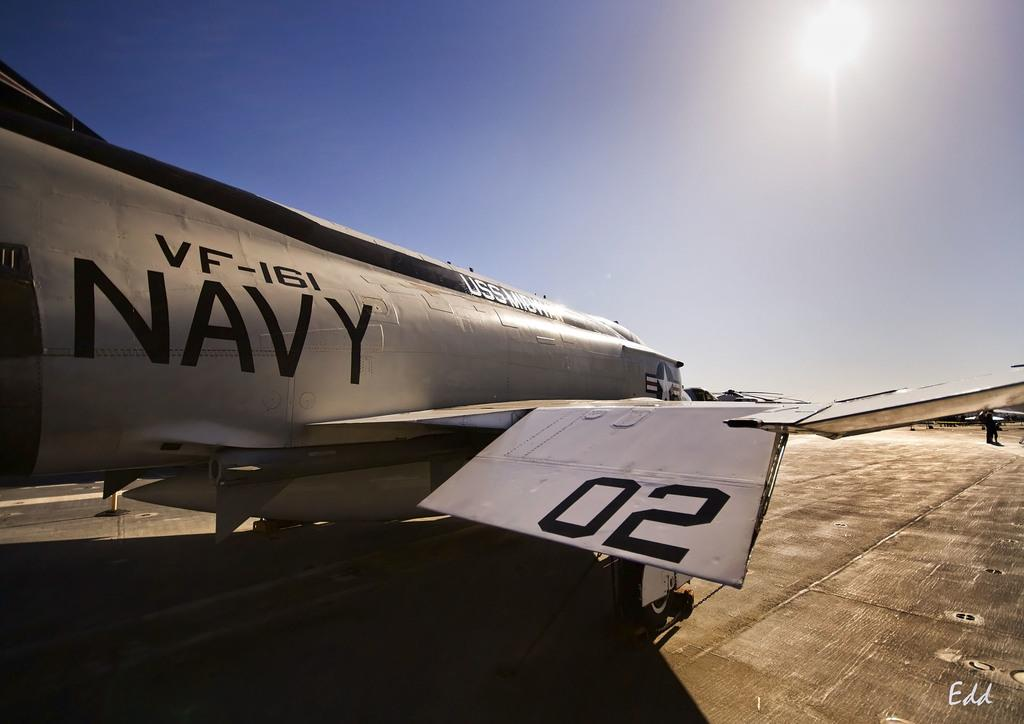Provide a one-sentence caption for the provided image. A grey navy fighter plane is from VF-161. 